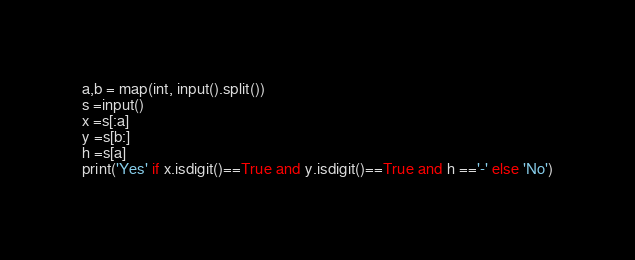<code> <loc_0><loc_0><loc_500><loc_500><_Python_>a,b = map(int, input().split())
s =input()
x =s[:a]
y =s[b:]
h =s[a]
print('Yes' if x.isdigit()==True and y.isdigit()==True and h =='-' else 'No')</code> 